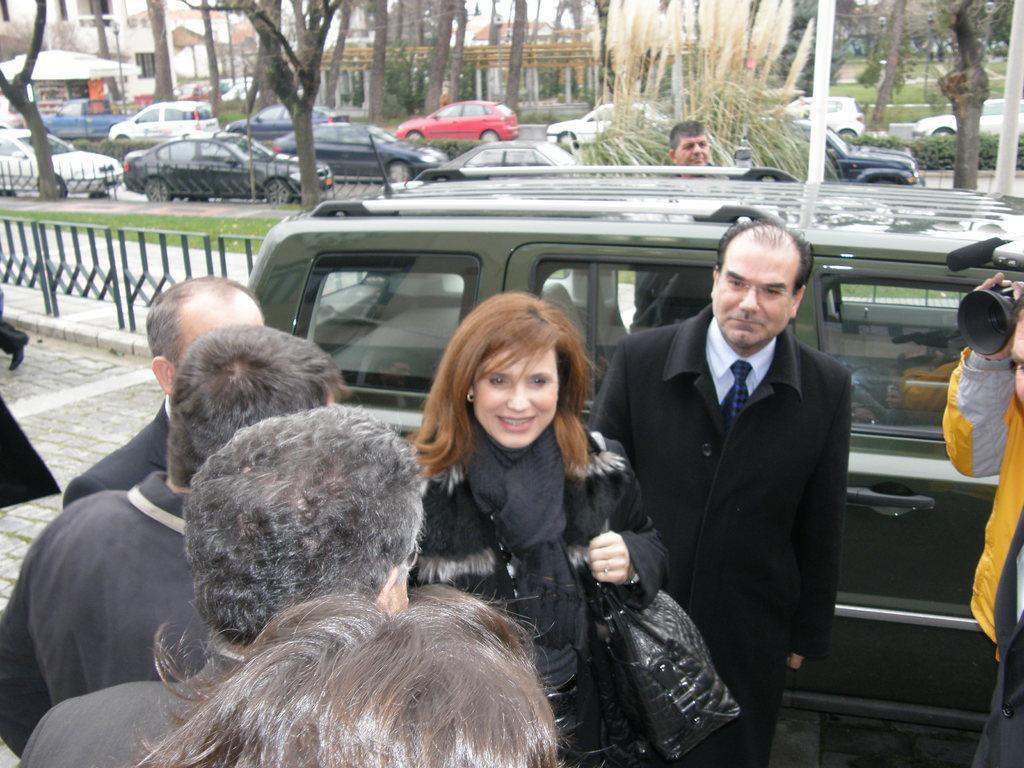Please provide a concise description of this image. This picture is clicked outside. In the center we can see the group of cars and we can see the group of persons, railings, green grass, sling bag, plants, trees, houses, tent and many other objects. 